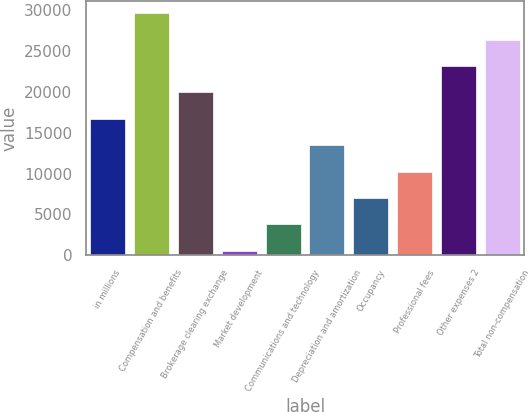<chart> <loc_0><loc_0><loc_500><loc_500><bar_chart><fcel>in millions<fcel>Compensation and benefits<fcel>Brokerage clearing exchange<fcel>Market development<fcel>Communications and technology<fcel>Depreciation and amortization<fcel>Occupancy<fcel>Professional fees<fcel>Other expenses 2<fcel>Total non-compensation<nl><fcel>16720.5<fcel>29664.1<fcel>19956.4<fcel>541<fcel>3776.9<fcel>13484.6<fcel>7012.8<fcel>10248.7<fcel>23192.3<fcel>26428.2<nl></chart> 